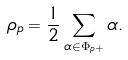<formula> <loc_0><loc_0><loc_500><loc_500>\rho _ { p } = \frac { 1 } { 2 } \sum _ { \alpha \in \Phi _ { p + } } \alpha .</formula> 